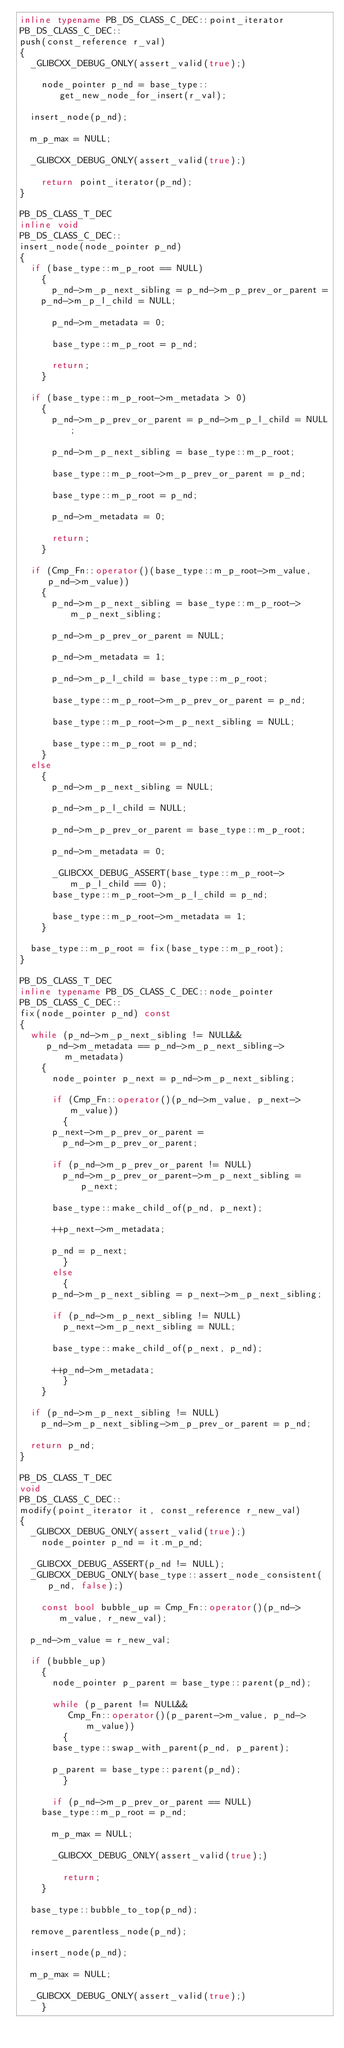<code> <loc_0><loc_0><loc_500><loc_500><_C++_>inline typename PB_DS_CLASS_C_DEC::point_iterator
PB_DS_CLASS_C_DEC::
push(const_reference r_val)
{
  _GLIBCXX_DEBUG_ONLY(assert_valid(true);)

    node_pointer p_nd = base_type::get_new_node_for_insert(r_val);

  insert_node(p_nd);

  m_p_max = NULL;

  _GLIBCXX_DEBUG_ONLY(assert_valid(true);)

    return point_iterator(p_nd);
}

PB_DS_CLASS_T_DEC
inline void
PB_DS_CLASS_C_DEC::
insert_node(node_pointer p_nd)
{
  if (base_type::m_p_root == NULL)
    {
      p_nd->m_p_next_sibling = p_nd->m_p_prev_or_parent =
	p_nd->m_p_l_child = NULL;

      p_nd->m_metadata = 0;

      base_type::m_p_root = p_nd;

      return;
    }

  if (base_type::m_p_root->m_metadata > 0)
    {
      p_nd->m_p_prev_or_parent = p_nd->m_p_l_child = NULL;

      p_nd->m_p_next_sibling = base_type::m_p_root;

      base_type::m_p_root->m_p_prev_or_parent = p_nd;

      base_type::m_p_root = p_nd;

      p_nd->m_metadata = 0;

      return;
    }

  if (Cmp_Fn::operator()(base_type::m_p_root->m_value, p_nd->m_value))
    {
      p_nd->m_p_next_sibling = base_type::m_p_root->m_p_next_sibling;

      p_nd->m_p_prev_or_parent = NULL;

      p_nd->m_metadata = 1;

      p_nd->m_p_l_child = base_type::m_p_root;

      base_type::m_p_root->m_p_prev_or_parent = p_nd;

      base_type::m_p_root->m_p_next_sibling = NULL;

      base_type::m_p_root = p_nd;
    }
  else
    {
      p_nd->m_p_next_sibling = NULL;

      p_nd->m_p_l_child = NULL;

      p_nd->m_p_prev_or_parent = base_type::m_p_root;

      p_nd->m_metadata = 0;

      _GLIBCXX_DEBUG_ASSERT(base_type::m_p_root->m_p_l_child == 0);
      base_type::m_p_root->m_p_l_child = p_nd;

      base_type::m_p_root->m_metadata = 1;
    }

  base_type::m_p_root = fix(base_type::m_p_root);
}

PB_DS_CLASS_T_DEC
inline typename PB_DS_CLASS_C_DEC::node_pointer
PB_DS_CLASS_C_DEC::
fix(node_pointer p_nd) const
{
  while (p_nd->m_p_next_sibling != NULL&& 
	 p_nd->m_metadata == p_nd->m_p_next_sibling->m_metadata)
    {
      node_pointer p_next = p_nd->m_p_next_sibling;

      if (Cmp_Fn::operator()(p_nd->m_value, p_next->m_value))
        {
	  p_next->m_p_prev_or_parent =
	    p_nd->m_p_prev_or_parent;

	  if (p_nd->m_p_prev_or_parent != NULL)
	    p_nd->m_p_prev_or_parent->m_p_next_sibling = p_next;

	  base_type::make_child_of(p_nd, p_next);

	  ++p_next->m_metadata;

	  p_nd = p_next;
        }
      else
        {
	  p_nd->m_p_next_sibling = p_next->m_p_next_sibling;

	  if (p_nd->m_p_next_sibling != NULL)
	    p_next->m_p_next_sibling = NULL;

	  base_type::make_child_of(p_next, p_nd);

	  ++p_nd->m_metadata;
        }
    }

  if (p_nd->m_p_next_sibling != NULL)
    p_nd->m_p_next_sibling->m_p_prev_or_parent = p_nd;

  return p_nd;
}

PB_DS_CLASS_T_DEC
void
PB_DS_CLASS_C_DEC::
modify(point_iterator it, const_reference r_new_val)
{
  _GLIBCXX_DEBUG_ONLY(assert_valid(true);)
    node_pointer p_nd = it.m_p_nd;

  _GLIBCXX_DEBUG_ASSERT(p_nd != NULL);
  _GLIBCXX_DEBUG_ONLY(base_type::assert_node_consistent(p_nd, false);)

    const bool bubble_up = Cmp_Fn::operator()(p_nd->m_value, r_new_val);

  p_nd->m_value = r_new_val;

  if (bubble_up)
    {
      node_pointer p_parent = base_type::parent(p_nd);

      while (p_parent != NULL&& 
	     Cmp_Fn::operator()(p_parent->m_value, p_nd->m_value))
        {
	  base_type::swap_with_parent(p_nd, p_parent);

	  p_parent = base_type::parent(p_nd);
        }

      if (p_nd->m_p_prev_or_parent == NULL)
	base_type::m_p_root = p_nd;

      m_p_max = NULL;

      _GLIBCXX_DEBUG_ONLY(assert_valid(true);)

        return;
    }

  base_type::bubble_to_top(p_nd);

  remove_parentless_node(p_nd);

  insert_node(p_nd);

  m_p_max = NULL;

  _GLIBCXX_DEBUG_ONLY(assert_valid(true);)
    }

</code> 